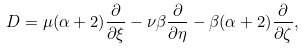Convert formula to latex. <formula><loc_0><loc_0><loc_500><loc_500>D = \mu ( \alpha + 2 ) \frac { \partial } { \partial \xi } - \nu \beta \frac { \partial } { \partial \eta } - \beta ( \alpha + 2 ) \frac { \partial } { \partial \zeta } ,</formula> 